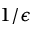<formula> <loc_0><loc_0><loc_500><loc_500>1 / \epsilon</formula> 